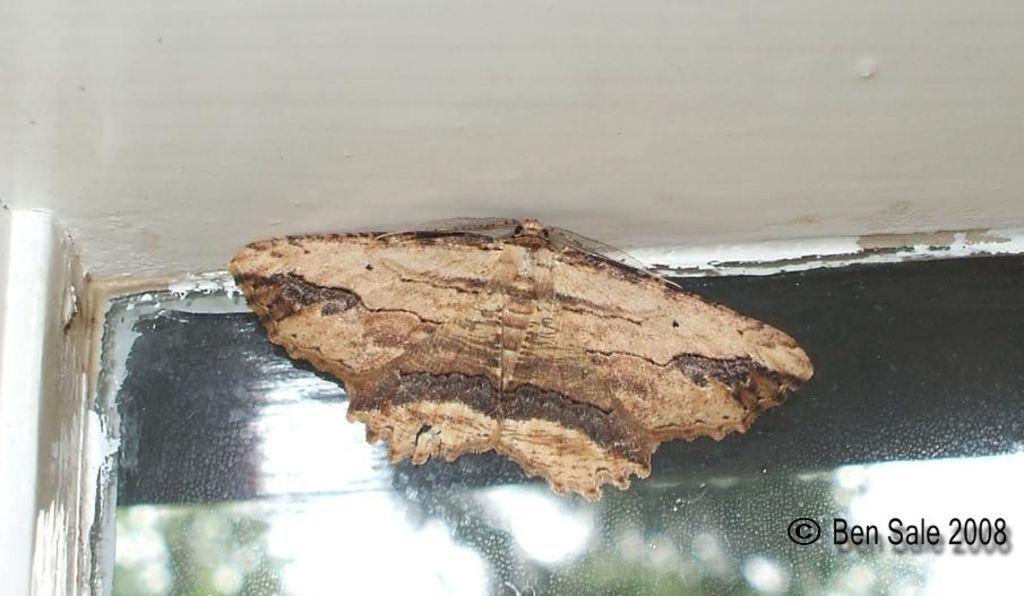Please provide a concise description of this image. In this picture I can see a insect on the wall. Here I can see a watermark. 